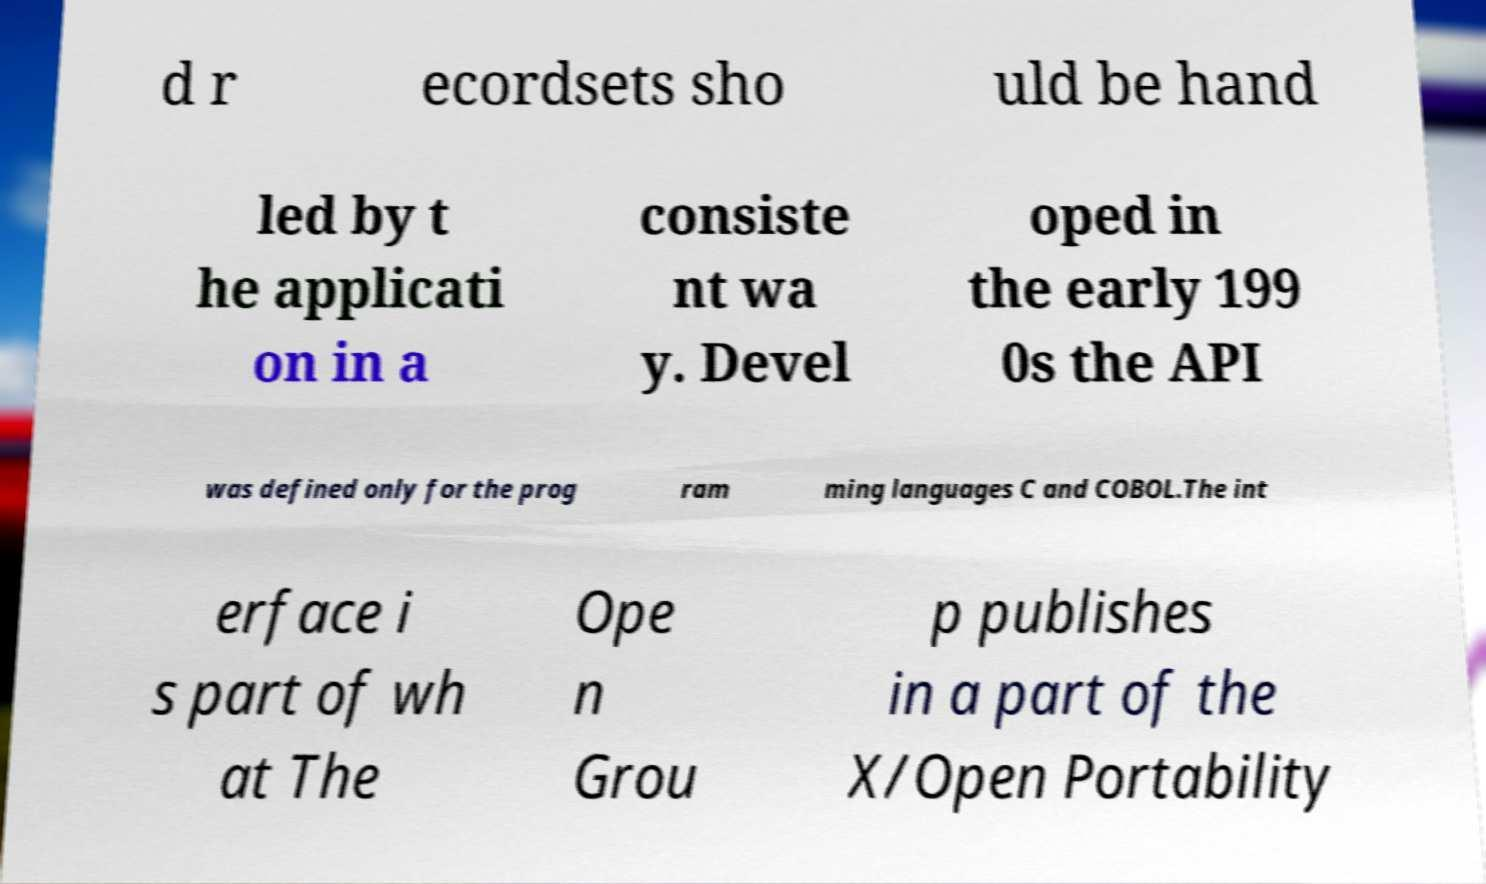I need the written content from this picture converted into text. Can you do that? d r ecordsets sho uld be hand led by t he applicati on in a consiste nt wa y. Devel oped in the early 199 0s the API was defined only for the prog ram ming languages C and COBOL.The int erface i s part of wh at The Ope n Grou p publishes in a part of the X/Open Portability 